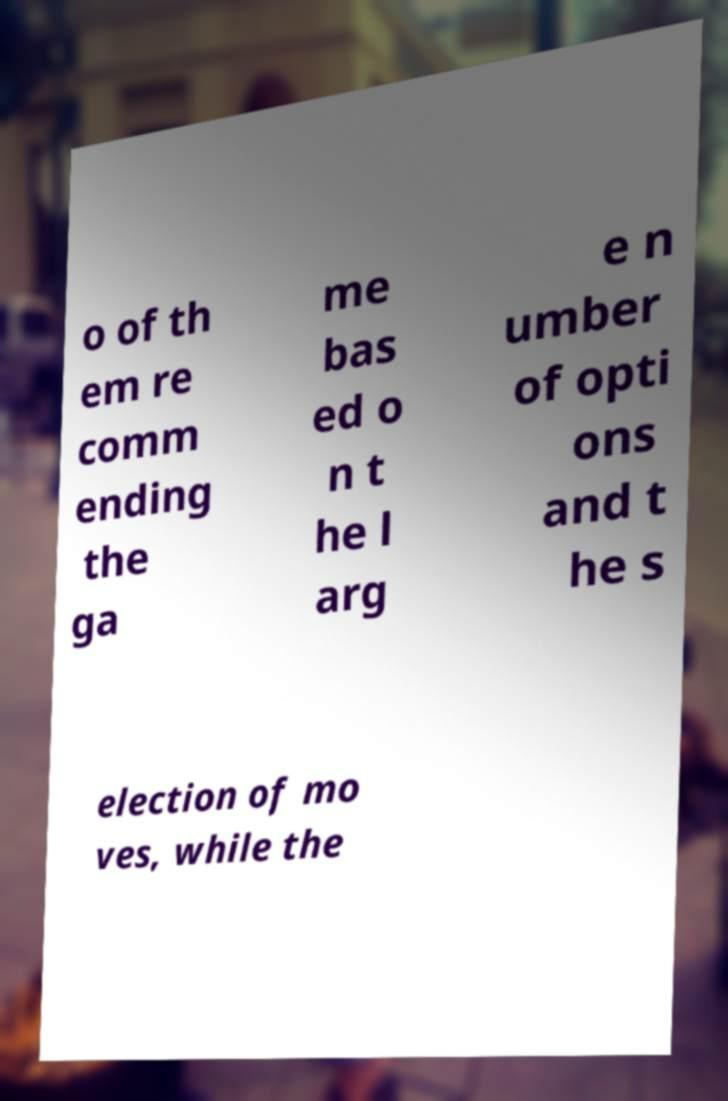I need the written content from this picture converted into text. Can you do that? o of th em re comm ending the ga me bas ed o n t he l arg e n umber of opti ons and t he s election of mo ves, while the 